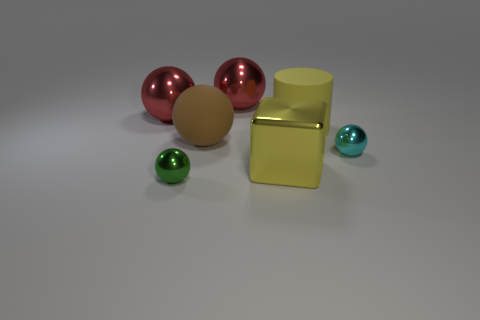How would you describe the lighting in this scene? The lighting in the scene is soft and diffuse, creating gentle shadows and a calm atmosphere that highlights the sleekness of the metallic objects. 